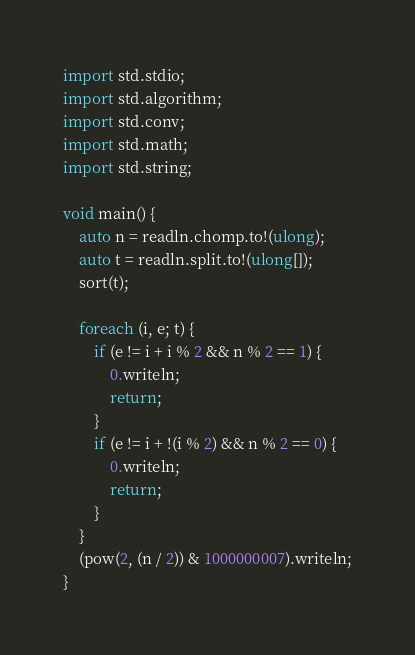Convert code to text. <code><loc_0><loc_0><loc_500><loc_500><_D_>import std.stdio;
import std.algorithm;
import std.conv;
import std.math;
import std.string;

void main() {
    auto n = readln.chomp.to!(ulong);
    auto t = readln.split.to!(ulong[]);
    sort(t);

    foreach (i, e; t) {
        if (e != i + i % 2 && n % 2 == 1) {
            0.writeln;
            return;
        }
        if (e != i + !(i % 2) && n % 2 == 0) {
            0.writeln;
            return;
        }
    }
    (pow(2, (n / 2)) & 1000000007).writeln;
}
</code> 